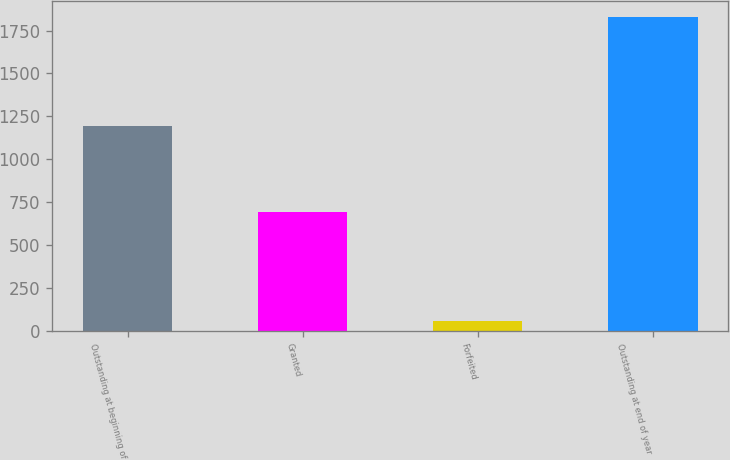Convert chart to OTSL. <chart><loc_0><loc_0><loc_500><loc_500><bar_chart><fcel>Outstanding at beginning of<fcel>Granted<fcel>Forfeited<fcel>Outstanding at end of year<nl><fcel>1194<fcel>696<fcel>60<fcel>1830<nl></chart> 